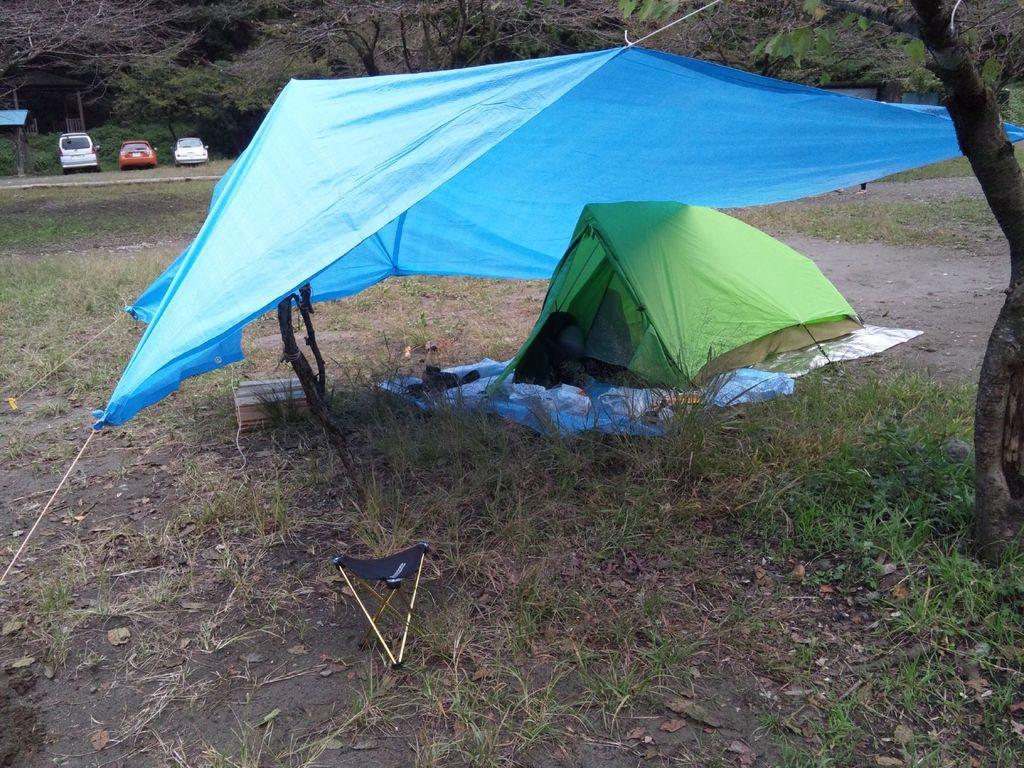Can you describe this image briefly? In this image I can see tents in different color. I can see trees,vehicles and shed. 